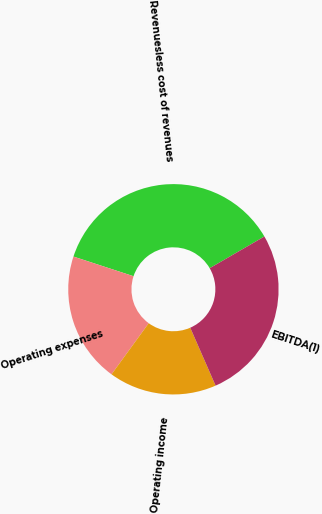Convert chart. <chart><loc_0><loc_0><loc_500><loc_500><pie_chart><fcel>Revenuesless cost of revenues<fcel>Operating expenses<fcel>Operating income<fcel>EBITDA(1)<nl><fcel>36.6%<fcel>20.02%<fcel>16.58%<fcel>26.8%<nl></chart> 